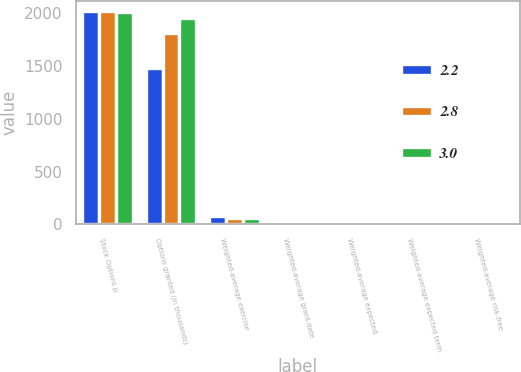Convert chart. <chart><loc_0><loc_0><loc_500><loc_500><stacked_bar_chart><ecel><fcel>Stock Options p<fcel>Options granted (in thousands)<fcel>Weighted-average exercise<fcel>Weighted-average grant-date<fcel>Weighted-average expected<fcel>Weighted-average expected term<fcel>Weighted-average risk-free<nl><fcel>2.2<fcel>2017<fcel>1480<fcel>82.99<fcel>17.12<fcel>2.2<fcel>5.1<fcel>2.1<nl><fcel>2.8<fcel>2016<fcel>1814<fcel>55.19<fcel>12.67<fcel>3<fcel>5.1<fcel>1.4<nl><fcel>3<fcel>2015<fcel>1954<fcel>57.2<fcel>10.38<fcel>2.8<fcel>5.3<fcel>1.6<nl></chart> 